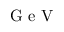Convert formula to latex. <formula><loc_0><loc_0><loc_500><loc_500>G e V</formula> 